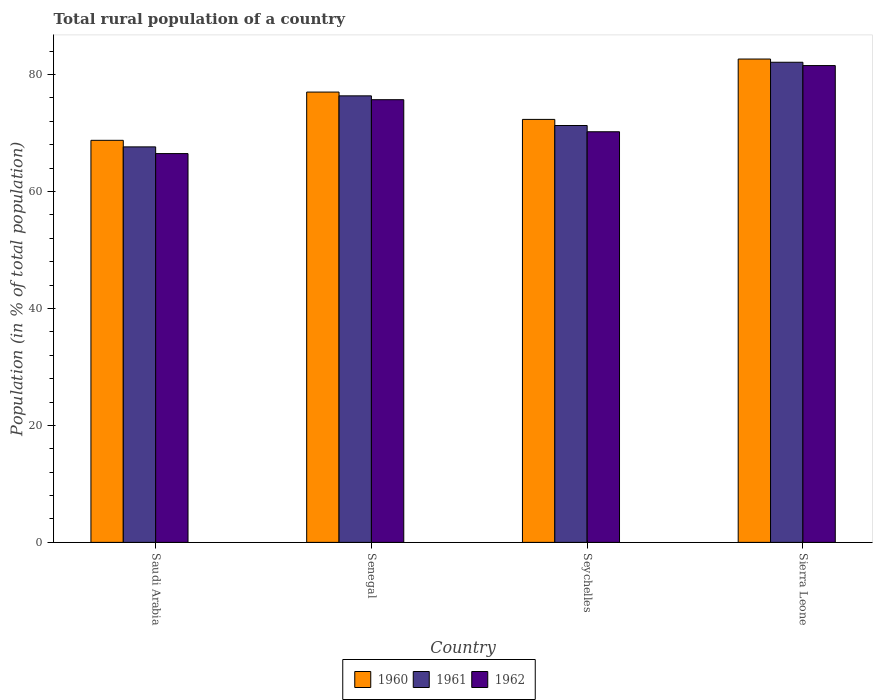How many different coloured bars are there?
Ensure brevity in your answer.  3. How many groups of bars are there?
Keep it short and to the point. 4. Are the number of bars on each tick of the X-axis equal?
Provide a succinct answer. Yes. How many bars are there on the 4th tick from the left?
Make the answer very short. 3. What is the label of the 2nd group of bars from the left?
Provide a short and direct response. Senegal. What is the rural population in 1961 in Saudi Arabia?
Provide a short and direct response. 67.63. Across all countries, what is the maximum rural population in 1960?
Keep it short and to the point. 82.65. Across all countries, what is the minimum rural population in 1960?
Offer a very short reply. 68.75. In which country was the rural population in 1962 maximum?
Offer a terse response. Sierra Leone. In which country was the rural population in 1961 minimum?
Provide a short and direct response. Saudi Arabia. What is the total rural population in 1960 in the graph?
Offer a very short reply. 300.73. What is the difference between the rural population in 1962 in Saudi Arabia and that in Senegal?
Your response must be concise. -9.22. What is the difference between the rural population in 1961 in Sierra Leone and the rural population in 1960 in Saudi Arabia?
Ensure brevity in your answer.  13.35. What is the average rural population in 1961 per country?
Offer a terse response. 74.34. What is the difference between the rural population of/in 1961 and rural population of/in 1962 in Senegal?
Ensure brevity in your answer.  0.66. What is the ratio of the rural population in 1962 in Seychelles to that in Sierra Leone?
Offer a terse response. 0.86. What is the difference between the highest and the second highest rural population in 1961?
Your answer should be very brief. 5.74. What is the difference between the highest and the lowest rural population in 1961?
Provide a short and direct response. 14.47. In how many countries, is the rural population in 1962 greater than the average rural population in 1962 taken over all countries?
Provide a short and direct response. 2. What does the 1st bar from the right in Saudi Arabia represents?
Provide a short and direct response. 1962. How many bars are there?
Provide a succinct answer. 12. Does the graph contain any zero values?
Offer a terse response. No. Does the graph contain grids?
Offer a very short reply. No. How are the legend labels stacked?
Make the answer very short. Horizontal. What is the title of the graph?
Offer a terse response. Total rural population of a country. What is the label or title of the Y-axis?
Your answer should be compact. Population (in % of total population). What is the Population (in % of total population) of 1960 in Saudi Arabia?
Provide a short and direct response. 68.75. What is the Population (in % of total population) of 1961 in Saudi Arabia?
Your answer should be very brief. 67.63. What is the Population (in % of total population) in 1962 in Saudi Arabia?
Ensure brevity in your answer.  66.48. What is the Population (in % of total population) in 1960 in Senegal?
Offer a terse response. 77. What is the Population (in % of total population) in 1961 in Senegal?
Give a very brief answer. 76.36. What is the Population (in % of total population) of 1962 in Senegal?
Your answer should be compact. 75.7. What is the Population (in % of total population) of 1960 in Seychelles?
Your answer should be compact. 72.33. What is the Population (in % of total population) in 1961 in Seychelles?
Your response must be concise. 71.28. What is the Population (in % of total population) in 1962 in Seychelles?
Provide a short and direct response. 70.21. What is the Population (in % of total population) in 1960 in Sierra Leone?
Offer a very short reply. 82.65. What is the Population (in % of total population) in 1961 in Sierra Leone?
Offer a terse response. 82.1. What is the Population (in % of total population) of 1962 in Sierra Leone?
Keep it short and to the point. 81.53. Across all countries, what is the maximum Population (in % of total population) of 1960?
Give a very brief answer. 82.65. Across all countries, what is the maximum Population (in % of total population) of 1961?
Provide a succinct answer. 82.1. Across all countries, what is the maximum Population (in % of total population) of 1962?
Ensure brevity in your answer.  81.53. Across all countries, what is the minimum Population (in % of total population) in 1960?
Give a very brief answer. 68.75. Across all countries, what is the minimum Population (in % of total population) of 1961?
Your answer should be very brief. 67.63. Across all countries, what is the minimum Population (in % of total population) of 1962?
Your response must be concise. 66.48. What is the total Population (in % of total population) in 1960 in the graph?
Keep it short and to the point. 300.73. What is the total Population (in % of total population) in 1961 in the graph?
Provide a short and direct response. 297.36. What is the total Population (in % of total population) in 1962 in the graph?
Keep it short and to the point. 293.93. What is the difference between the Population (in % of total population) of 1960 in Saudi Arabia and that in Senegal?
Make the answer very short. -8.25. What is the difference between the Population (in % of total population) of 1961 in Saudi Arabia and that in Senegal?
Provide a short and direct response. -8.73. What is the difference between the Population (in % of total population) of 1962 in Saudi Arabia and that in Senegal?
Give a very brief answer. -9.21. What is the difference between the Population (in % of total population) of 1960 in Saudi Arabia and that in Seychelles?
Ensure brevity in your answer.  -3.58. What is the difference between the Population (in % of total population) of 1961 in Saudi Arabia and that in Seychelles?
Keep it short and to the point. -3.66. What is the difference between the Population (in % of total population) in 1962 in Saudi Arabia and that in Seychelles?
Provide a succinct answer. -3.73. What is the difference between the Population (in % of total population) of 1960 in Saudi Arabia and that in Sierra Leone?
Offer a very short reply. -13.9. What is the difference between the Population (in % of total population) of 1961 in Saudi Arabia and that in Sierra Leone?
Your response must be concise. -14.47. What is the difference between the Population (in % of total population) of 1962 in Saudi Arabia and that in Sierra Leone?
Give a very brief answer. -15.05. What is the difference between the Population (in % of total population) of 1960 in Senegal and that in Seychelles?
Give a very brief answer. 4.67. What is the difference between the Population (in % of total population) of 1961 in Senegal and that in Seychelles?
Offer a very short reply. 5.07. What is the difference between the Population (in % of total population) in 1962 in Senegal and that in Seychelles?
Provide a short and direct response. 5.48. What is the difference between the Population (in % of total population) of 1960 in Senegal and that in Sierra Leone?
Provide a short and direct response. -5.65. What is the difference between the Population (in % of total population) in 1961 in Senegal and that in Sierra Leone?
Offer a terse response. -5.74. What is the difference between the Population (in % of total population) in 1962 in Senegal and that in Sierra Leone?
Give a very brief answer. -5.84. What is the difference between the Population (in % of total population) of 1960 in Seychelles and that in Sierra Leone?
Provide a succinct answer. -10.32. What is the difference between the Population (in % of total population) in 1961 in Seychelles and that in Sierra Leone?
Give a very brief answer. -10.81. What is the difference between the Population (in % of total population) of 1962 in Seychelles and that in Sierra Leone?
Provide a succinct answer. -11.32. What is the difference between the Population (in % of total population) in 1960 in Saudi Arabia and the Population (in % of total population) in 1961 in Senegal?
Make the answer very short. -7.61. What is the difference between the Population (in % of total population) in 1960 in Saudi Arabia and the Population (in % of total population) in 1962 in Senegal?
Provide a succinct answer. -6.95. What is the difference between the Population (in % of total population) in 1961 in Saudi Arabia and the Population (in % of total population) in 1962 in Senegal?
Keep it short and to the point. -8.07. What is the difference between the Population (in % of total population) in 1960 in Saudi Arabia and the Population (in % of total population) in 1961 in Seychelles?
Ensure brevity in your answer.  -2.53. What is the difference between the Population (in % of total population) in 1960 in Saudi Arabia and the Population (in % of total population) in 1962 in Seychelles?
Make the answer very short. -1.46. What is the difference between the Population (in % of total population) of 1961 in Saudi Arabia and the Population (in % of total population) of 1962 in Seychelles?
Keep it short and to the point. -2.59. What is the difference between the Population (in % of total population) in 1960 in Saudi Arabia and the Population (in % of total population) in 1961 in Sierra Leone?
Ensure brevity in your answer.  -13.35. What is the difference between the Population (in % of total population) of 1960 in Saudi Arabia and the Population (in % of total population) of 1962 in Sierra Leone?
Provide a succinct answer. -12.78. What is the difference between the Population (in % of total population) of 1961 in Saudi Arabia and the Population (in % of total population) of 1962 in Sierra Leone?
Keep it short and to the point. -13.91. What is the difference between the Population (in % of total population) of 1960 in Senegal and the Population (in % of total population) of 1961 in Seychelles?
Ensure brevity in your answer.  5.72. What is the difference between the Population (in % of total population) of 1960 in Senegal and the Population (in % of total population) of 1962 in Seychelles?
Offer a terse response. 6.79. What is the difference between the Population (in % of total population) of 1961 in Senegal and the Population (in % of total population) of 1962 in Seychelles?
Your answer should be compact. 6.14. What is the difference between the Population (in % of total population) of 1960 in Senegal and the Population (in % of total population) of 1961 in Sierra Leone?
Offer a very short reply. -5.1. What is the difference between the Population (in % of total population) in 1960 in Senegal and the Population (in % of total population) in 1962 in Sierra Leone?
Give a very brief answer. -4.53. What is the difference between the Population (in % of total population) in 1961 in Senegal and the Population (in % of total population) in 1962 in Sierra Leone?
Your answer should be compact. -5.18. What is the difference between the Population (in % of total population) in 1960 in Seychelles and the Population (in % of total population) in 1961 in Sierra Leone?
Offer a terse response. -9.77. What is the difference between the Population (in % of total population) in 1960 in Seychelles and the Population (in % of total population) in 1962 in Sierra Leone?
Your response must be concise. -9.21. What is the difference between the Population (in % of total population) of 1961 in Seychelles and the Population (in % of total population) of 1962 in Sierra Leone?
Your response must be concise. -10.25. What is the average Population (in % of total population) in 1960 per country?
Make the answer very short. 75.18. What is the average Population (in % of total population) of 1961 per country?
Make the answer very short. 74.34. What is the average Population (in % of total population) of 1962 per country?
Keep it short and to the point. 73.48. What is the difference between the Population (in % of total population) in 1960 and Population (in % of total population) in 1961 in Saudi Arabia?
Offer a terse response. 1.12. What is the difference between the Population (in % of total population) in 1960 and Population (in % of total population) in 1962 in Saudi Arabia?
Ensure brevity in your answer.  2.27. What is the difference between the Population (in % of total population) in 1961 and Population (in % of total population) in 1962 in Saudi Arabia?
Your response must be concise. 1.15. What is the difference between the Population (in % of total population) of 1960 and Population (in % of total population) of 1961 in Senegal?
Give a very brief answer. 0.65. What is the difference between the Population (in % of total population) in 1960 and Population (in % of total population) in 1962 in Senegal?
Your answer should be compact. 1.3. What is the difference between the Population (in % of total population) in 1961 and Population (in % of total population) in 1962 in Senegal?
Make the answer very short. 0.66. What is the difference between the Population (in % of total population) in 1960 and Population (in % of total population) in 1961 in Seychelles?
Provide a succinct answer. 1.04. What is the difference between the Population (in % of total population) of 1960 and Population (in % of total population) of 1962 in Seychelles?
Your answer should be compact. 2.11. What is the difference between the Population (in % of total population) in 1961 and Population (in % of total population) in 1962 in Seychelles?
Offer a very short reply. 1.07. What is the difference between the Population (in % of total population) in 1960 and Population (in % of total population) in 1961 in Sierra Leone?
Provide a succinct answer. 0.55. What is the difference between the Population (in % of total population) in 1960 and Population (in % of total population) in 1962 in Sierra Leone?
Provide a short and direct response. 1.11. What is the difference between the Population (in % of total population) of 1961 and Population (in % of total population) of 1962 in Sierra Leone?
Provide a succinct answer. 0.56. What is the ratio of the Population (in % of total population) of 1960 in Saudi Arabia to that in Senegal?
Your answer should be compact. 0.89. What is the ratio of the Population (in % of total population) of 1961 in Saudi Arabia to that in Senegal?
Ensure brevity in your answer.  0.89. What is the ratio of the Population (in % of total population) of 1962 in Saudi Arabia to that in Senegal?
Provide a short and direct response. 0.88. What is the ratio of the Population (in % of total population) in 1960 in Saudi Arabia to that in Seychelles?
Offer a terse response. 0.95. What is the ratio of the Population (in % of total population) in 1961 in Saudi Arabia to that in Seychelles?
Keep it short and to the point. 0.95. What is the ratio of the Population (in % of total population) of 1962 in Saudi Arabia to that in Seychelles?
Your answer should be very brief. 0.95. What is the ratio of the Population (in % of total population) of 1960 in Saudi Arabia to that in Sierra Leone?
Your response must be concise. 0.83. What is the ratio of the Population (in % of total population) in 1961 in Saudi Arabia to that in Sierra Leone?
Your answer should be compact. 0.82. What is the ratio of the Population (in % of total population) in 1962 in Saudi Arabia to that in Sierra Leone?
Make the answer very short. 0.82. What is the ratio of the Population (in % of total population) in 1960 in Senegal to that in Seychelles?
Make the answer very short. 1.06. What is the ratio of the Population (in % of total population) in 1961 in Senegal to that in Seychelles?
Your answer should be compact. 1.07. What is the ratio of the Population (in % of total population) of 1962 in Senegal to that in Seychelles?
Provide a succinct answer. 1.08. What is the ratio of the Population (in % of total population) of 1960 in Senegal to that in Sierra Leone?
Give a very brief answer. 0.93. What is the ratio of the Population (in % of total population) of 1961 in Senegal to that in Sierra Leone?
Give a very brief answer. 0.93. What is the ratio of the Population (in % of total population) in 1962 in Senegal to that in Sierra Leone?
Give a very brief answer. 0.93. What is the ratio of the Population (in % of total population) of 1960 in Seychelles to that in Sierra Leone?
Your answer should be compact. 0.88. What is the ratio of the Population (in % of total population) of 1961 in Seychelles to that in Sierra Leone?
Make the answer very short. 0.87. What is the ratio of the Population (in % of total population) in 1962 in Seychelles to that in Sierra Leone?
Your answer should be compact. 0.86. What is the difference between the highest and the second highest Population (in % of total population) of 1960?
Provide a short and direct response. 5.65. What is the difference between the highest and the second highest Population (in % of total population) of 1961?
Ensure brevity in your answer.  5.74. What is the difference between the highest and the second highest Population (in % of total population) in 1962?
Offer a very short reply. 5.84. What is the difference between the highest and the lowest Population (in % of total population) in 1960?
Provide a succinct answer. 13.9. What is the difference between the highest and the lowest Population (in % of total population) of 1961?
Provide a succinct answer. 14.47. What is the difference between the highest and the lowest Population (in % of total population) of 1962?
Ensure brevity in your answer.  15.05. 